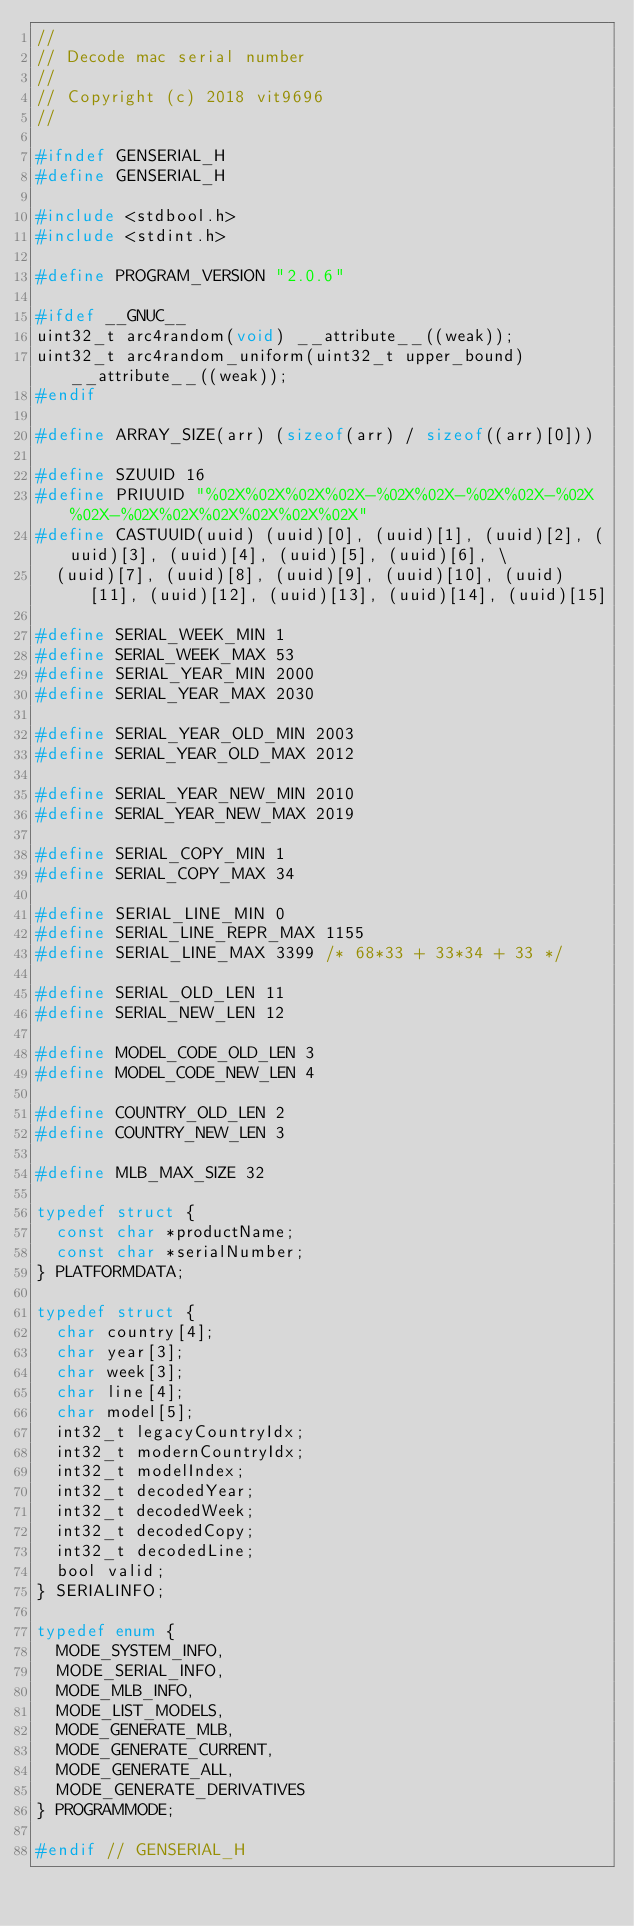<code> <loc_0><loc_0><loc_500><loc_500><_C_>//
// Decode mac serial number
//
// Copyright (c) 2018 vit9696
//

#ifndef GENSERIAL_H
#define GENSERIAL_H

#include <stdbool.h>
#include <stdint.h>

#define PROGRAM_VERSION "2.0.6"

#ifdef __GNUC__
uint32_t arc4random(void) __attribute__((weak));
uint32_t arc4random_uniform(uint32_t upper_bound) __attribute__((weak));
#endif

#define ARRAY_SIZE(arr) (sizeof(arr) / sizeof((arr)[0]))

#define SZUUID 16
#define PRIUUID "%02X%02X%02X%02X-%02X%02X-%02X%02X-%02X%02X-%02X%02X%02X%02X%02X%02X"
#define CASTUUID(uuid) (uuid)[0], (uuid)[1], (uuid)[2], (uuid)[3], (uuid)[4], (uuid)[5], (uuid)[6], \
  (uuid)[7], (uuid)[8], (uuid)[9], (uuid)[10], (uuid)[11], (uuid)[12], (uuid)[13], (uuid)[14], (uuid)[15]

#define SERIAL_WEEK_MIN 1
#define SERIAL_WEEK_MAX 53
#define SERIAL_YEAR_MIN 2000
#define SERIAL_YEAR_MAX 2030

#define SERIAL_YEAR_OLD_MIN 2003
#define SERIAL_YEAR_OLD_MAX 2012

#define SERIAL_YEAR_NEW_MIN 2010
#define SERIAL_YEAR_NEW_MAX 2019

#define SERIAL_COPY_MIN 1
#define SERIAL_COPY_MAX 34

#define SERIAL_LINE_MIN 0
#define SERIAL_LINE_REPR_MAX 1155
#define SERIAL_LINE_MAX 3399 /* 68*33 + 33*34 + 33 */

#define SERIAL_OLD_LEN 11
#define SERIAL_NEW_LEN 12

#define MODEL_CODE_OLD_LEN 3
#define MODEL_CODE_NEW_LEN 4

#define COUNTRY_OLD_LEN 2
#define COUNTRY_NEW_LEN 3

#define MLB_MAX_SIZE 32

typedef struct {
  const char *productName;
  const char *serialNumber;
} PLATFORMDATA;

typedef struct {
  char country[4];
  char year[3];
  char week[3];
  char line[4];
  char model[5];
  int32_t legacyCountryIdx;
  int32_t modernCountryIdx;
  int32_t modelIndex;
  int32_t decodedYear;
  int32_t decodedWeek;
  int32_t decodedCopy;
  int32_t decodedLine;
  bool valid;
} SERIALINFO;

typedef enum {
  MODE_SYSTEM_INFO,
  MODE_SERIAL_INFO,
  MODE_MLB_INFO,
  MODE_LIST_MODELS,
  MODE_GENERATE_MLB,
  MODE_GENERATE_CURRENT,
  MODE_GENERATE_ALL,
  MODE_GENERATE_DERIVATIVES
} PROGRAMMODE;

#endif // GENSERIAL_H
</code> 